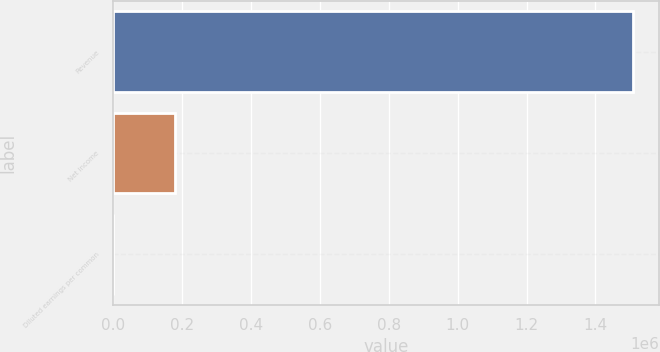Convert chart to OTSL. <chart><loc_0><loc_0><loc_500><loc_500><bar_chart><fcel>Revenue<fcel>Net income<fcel>Diluted earnings per common<nl><fcel>1.50971e+06<fcel>177443<fcel>0.93<nl></chart> 